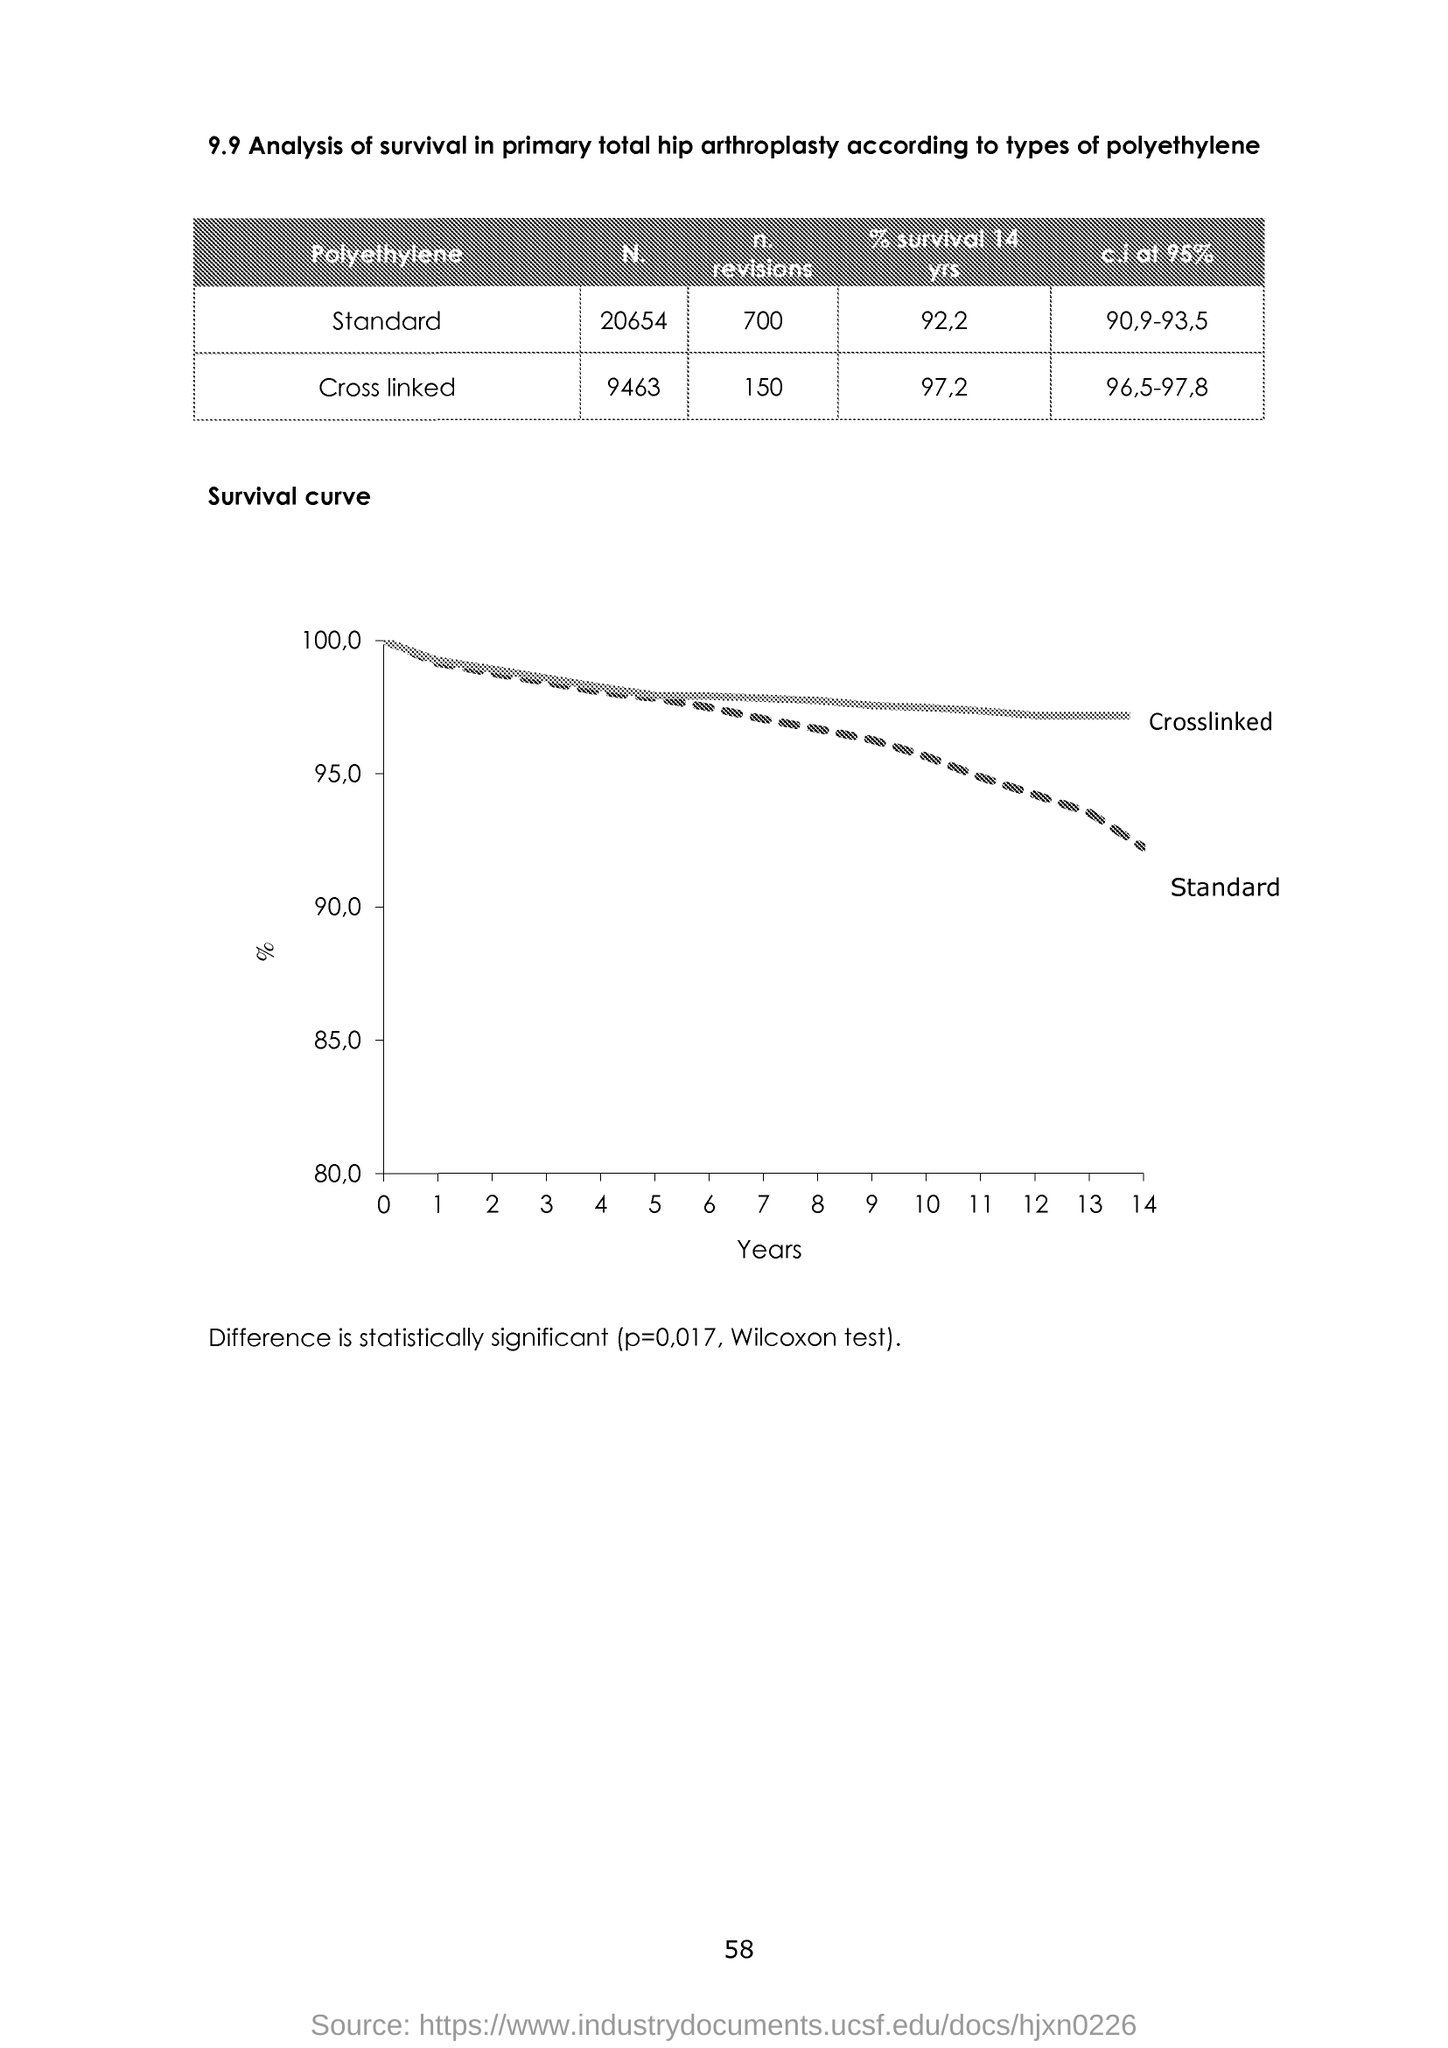Mention a couple of crucial points in this snapshot. The x-axis displays the years of data that are plotted in the graph. The value of p is 0.017. 